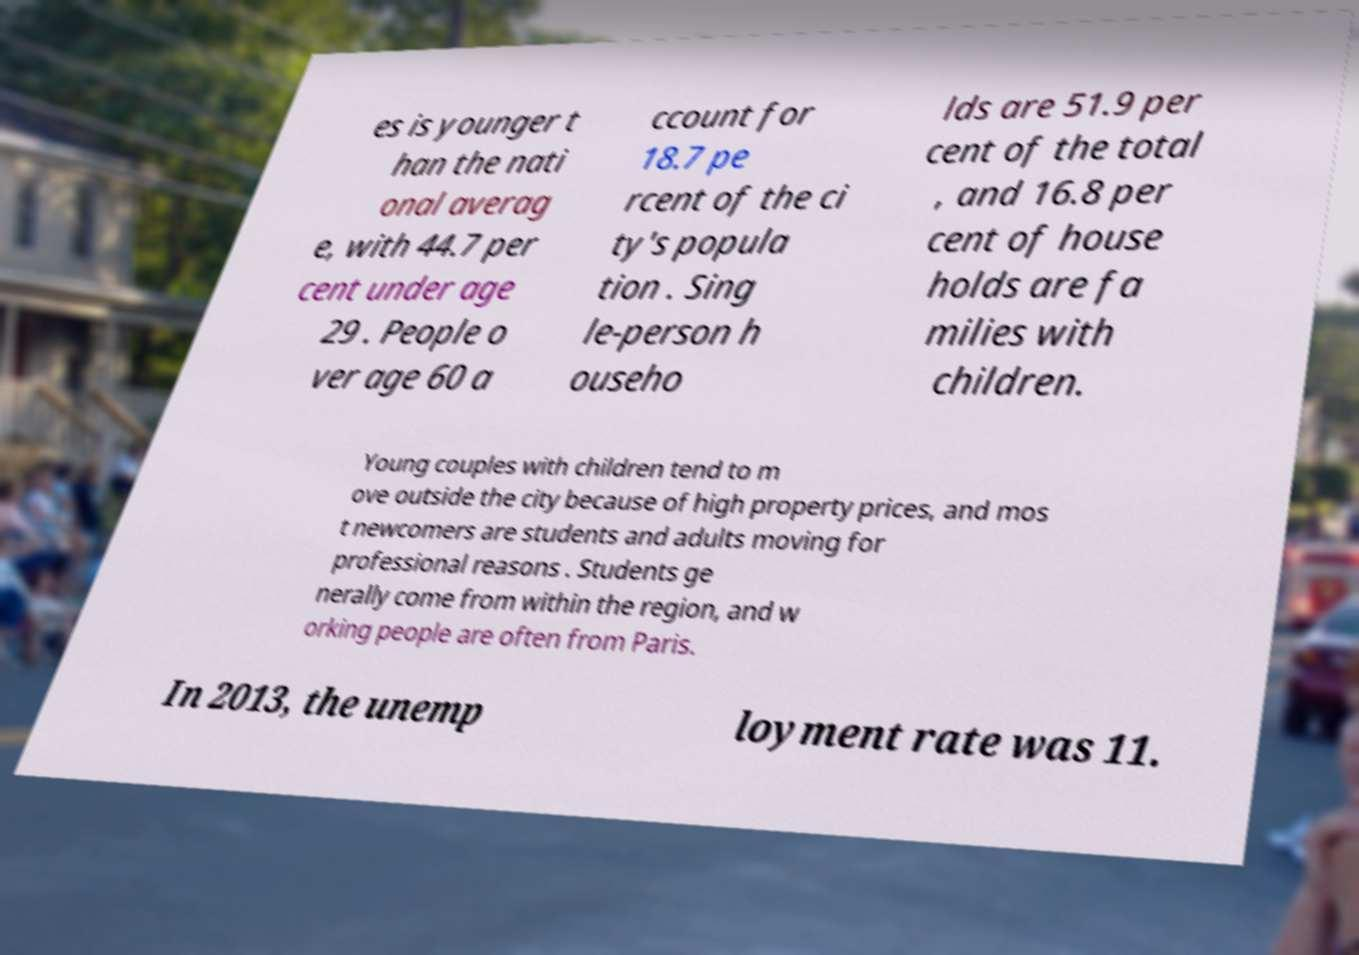For documentation purposes, I need the text within this image transcribed. Could you provide that? es is younger t han the nati onal averag e, with 44.7 per cent under age 29 . People o ver age 60 a ccount for 18.7 pe rcent of the ci ty's popula tion . Sing le-person h ouseho lds are 51.9 per cent of the total , and 16.8 per cent of house holds are fa milies with children. Young couples with children tend to m ove outside the city because of high property prices, and mos t newcomers are students and adults moving for professional reasons . Students ge nerally come from within the region, and w orking people are often from Paris. In 2013, the unemp loyment rate was 11. 